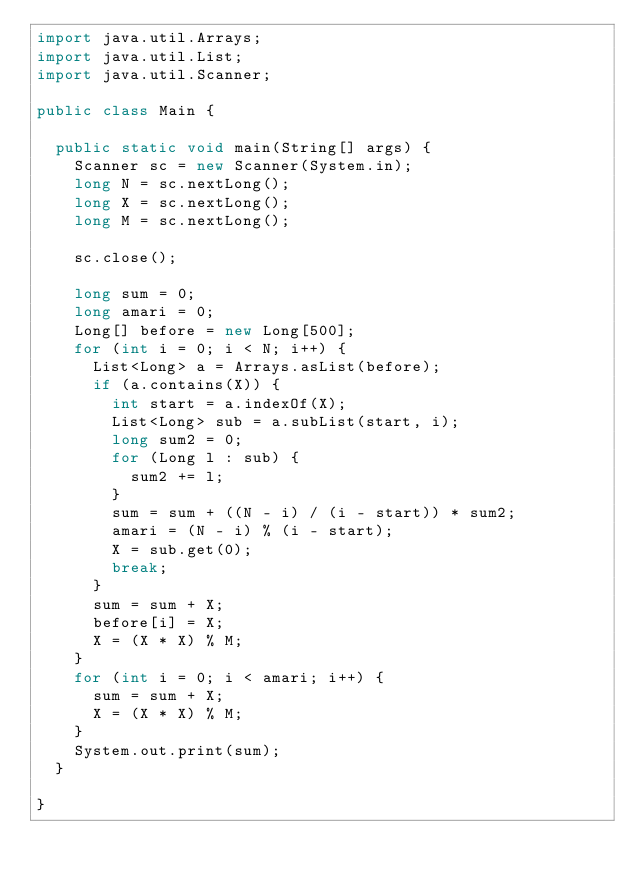<code> <loc_0><loc_0><loc_500><loc_500><_Java_>import java.util.Arrays;
import java.util.List;
import java.util.Scanner;

public class Main {

	public static void main(String[] args) {
		Scanner sc = new Scanner(System.in);
		long N = sc.nextLong();
		long X = sc.nextLong();
		long M = sc.nextLong();

		sc.close();

		long sum = 0;
		long amari = 0;
		Long[] before = new Long[500];
		for (int i = 0; i < N; i++) {
			List<Long> a = Arrays.asList(before);
			if (a.contains(X)) {
				int start = a.indexOf(X);
				List<Long> sub = a.subList(start, i);
				long sum2 = 0;
				for (Long l : sub) {
					sum2 += l;
				}
				sum = sum + ((N - i) / (i - start)) * sum2;
				amari = (N - i) % (i - start);
				X = sub.get(0);
				break;
			}
			sum = sum + X;
			before[i] = X;
			X = (X * X) % M;
		}
		for (int i = 0; i < amari; i++) {
			sum = sum + X;
			X = (X * X) % M;
		}
		System.out.print(sum);
	}

}
</code> 